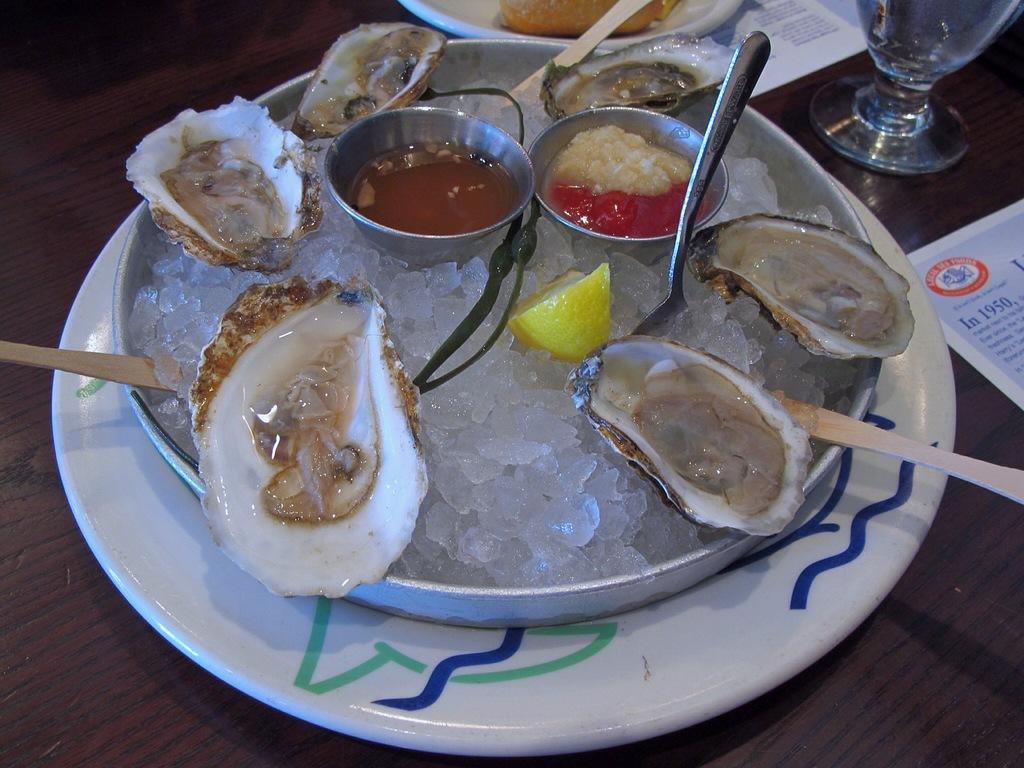What utensils can be seen in the image? There are spoons in the image. What is the color of the plate that holds the food items? The plate is white. What type of container is present for holding a beverage? There is a glass in the image. What is the surface on which the food items and glass are placed? There are other objects on a wooden table in the image. Can you tell me how many men are playing in the band in the image? There is no band or men present in the image; it features spoons, food items on a plate, a glass, and other objects on a wooden table. What type of vegetable is visible in the image? There is no vegetable, specifically celery, present in the image. 